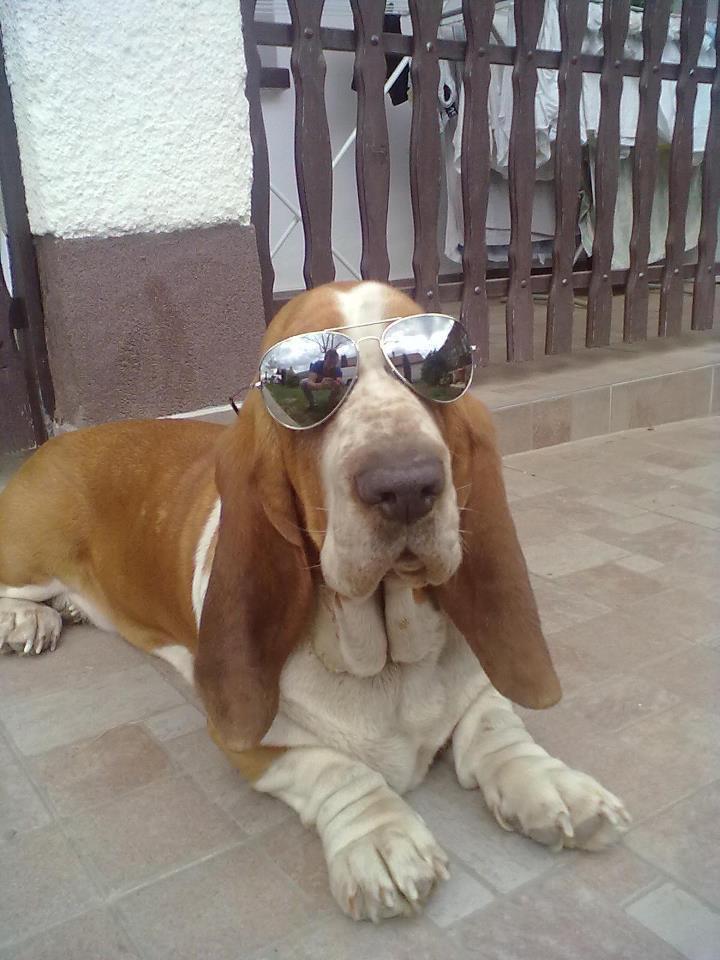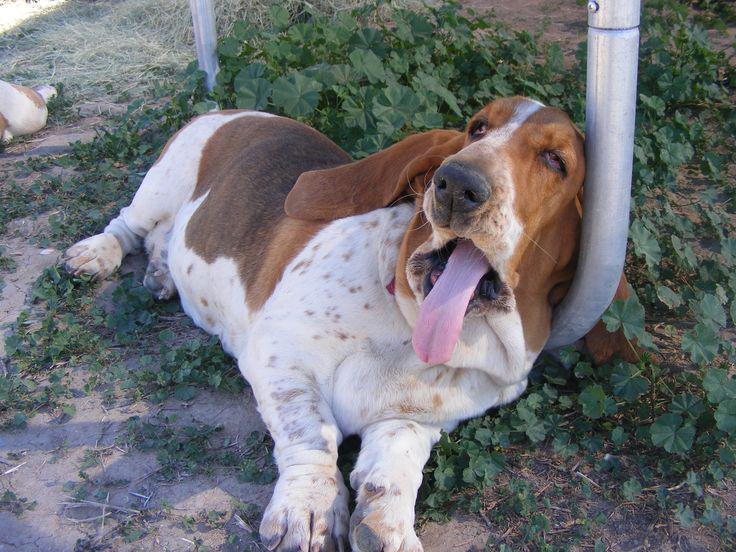The first image is the image on the left, the second image is the image on the right. For the images shown, is this caption "At least one dog is laying down." true? Answer yes or no. Yes. The first image is the image on the left, the second image is the image on the right. Examine the images to the left and right. Is the description "In one of the images, there are at least four dogs." accurate? Answer yes or no. No. 